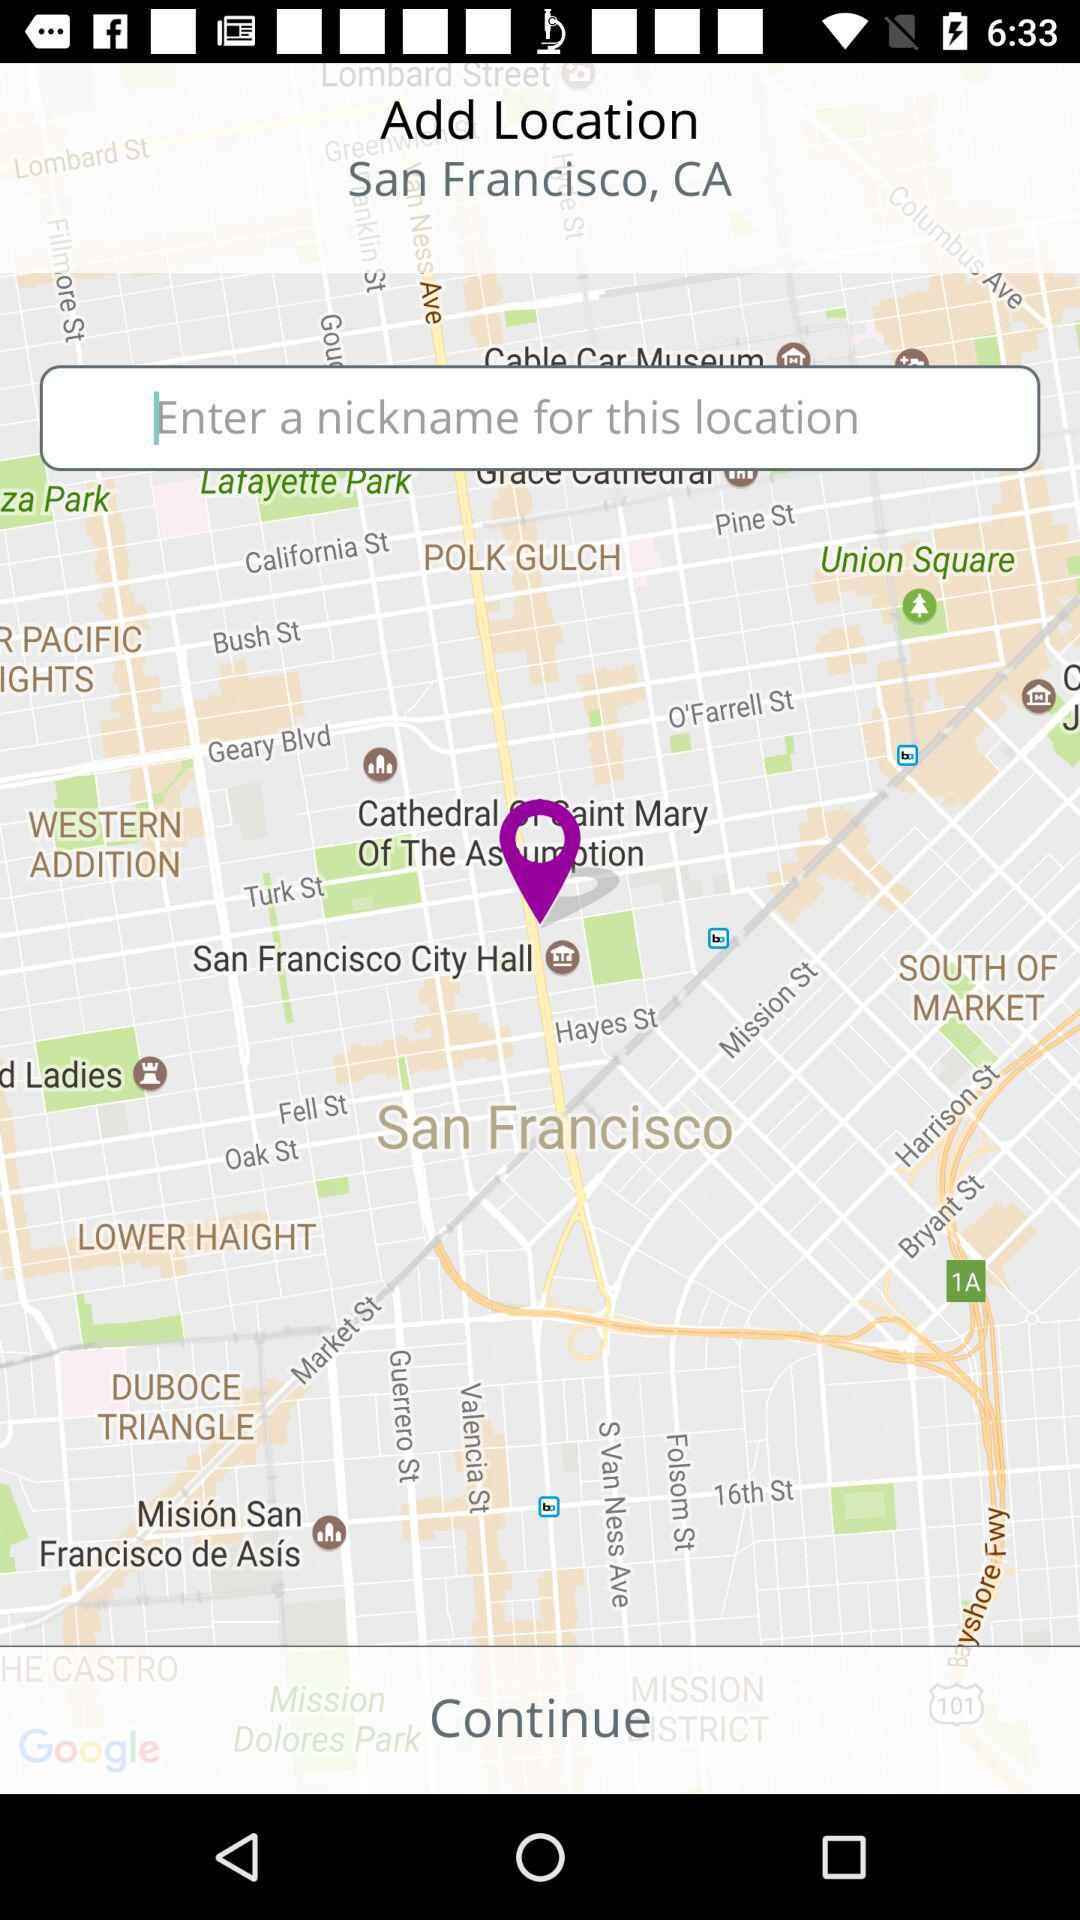What is the pinpoint location? The pinpoint location is San Francisco City Hall. 